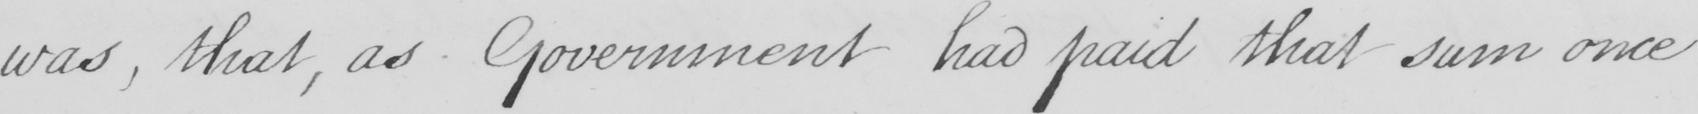What is written in this line of handwriting? was  , that , as Government had paid that sum once 